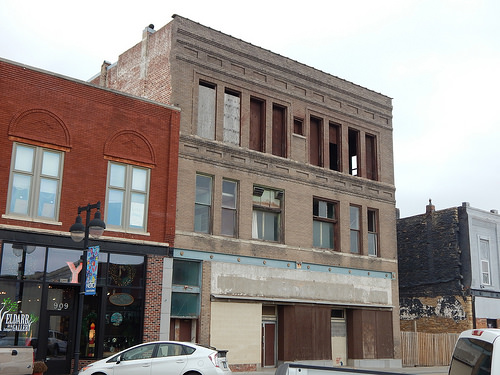<image>
Is the car to the left of the building? Yes. From this viewpoint, the car is positioned to the left side relative to the building. 